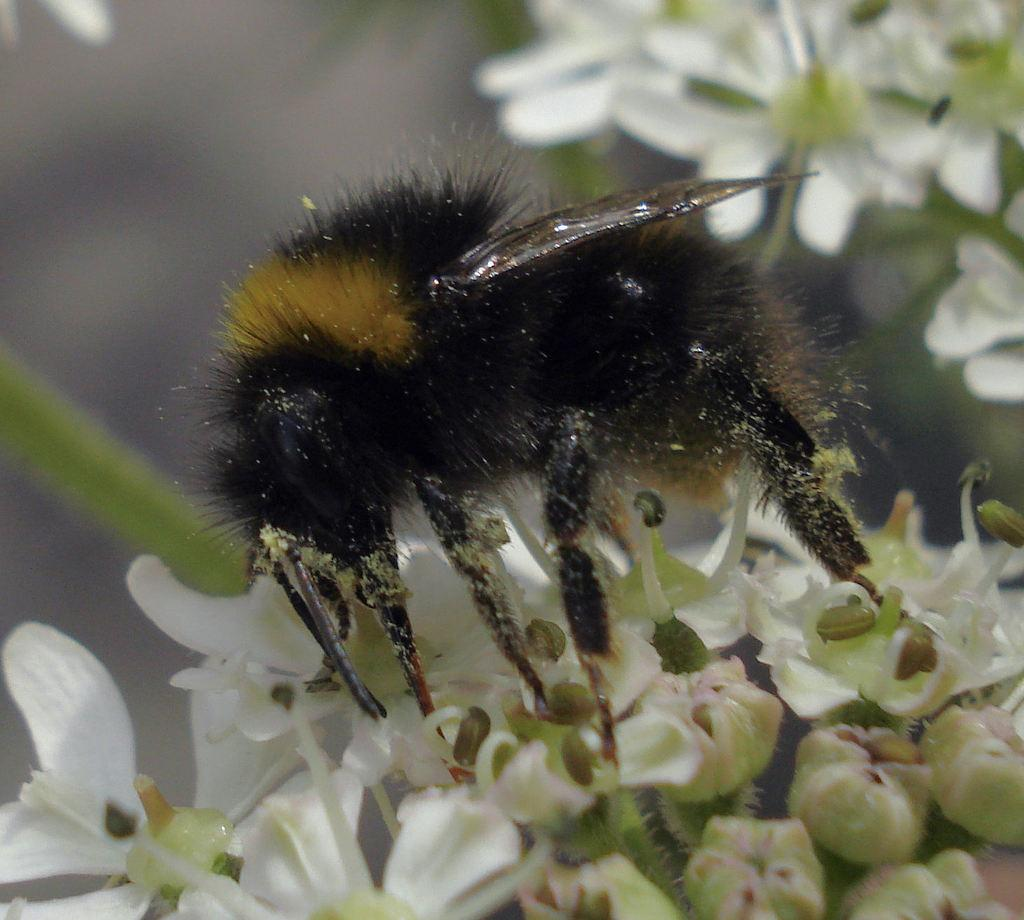What is present in the image? There is an insect in the image. What color is the insect? The insect is black in color. What is the insect standing on? The insect is standing on white flowers. What type of plastic is the duck made of in the image? There is no duck present in the image, and therefore no plastic duck to describe. 